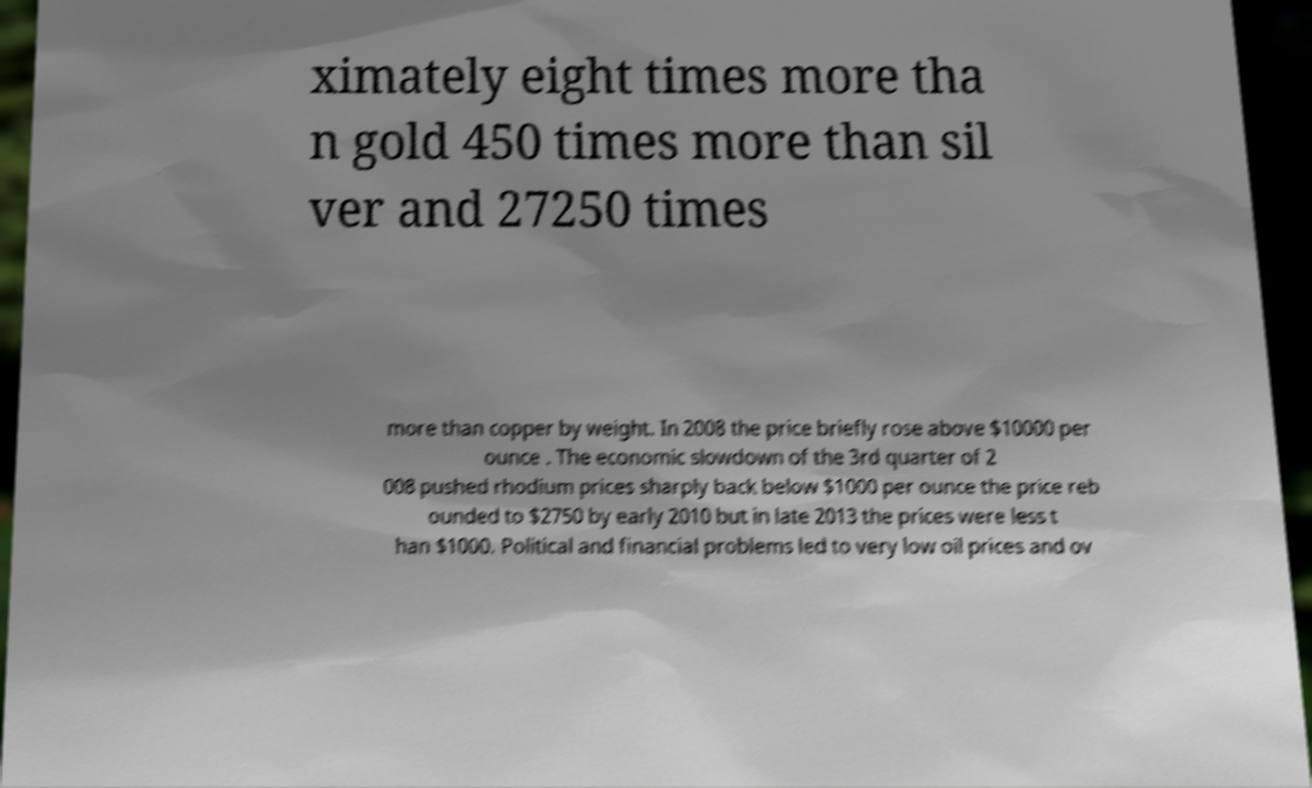For documentation purposes, I need the text within this image transcribed. Could you provide that? ximately eight times more tha n gold 450 times more than sil ver and 27250 times more than copper by weight. In 2008 the price briefly rose above $10000 per ounce . The economic slowdown of the 3rd quarter of 2 008 pushed rhodium prices sharply back below $1000 per ounce the price reb ounded to $2750 by early 2010 but in late 2013 the prices were less t han $1000. Political and financial problems led to very low oil prices and ov 